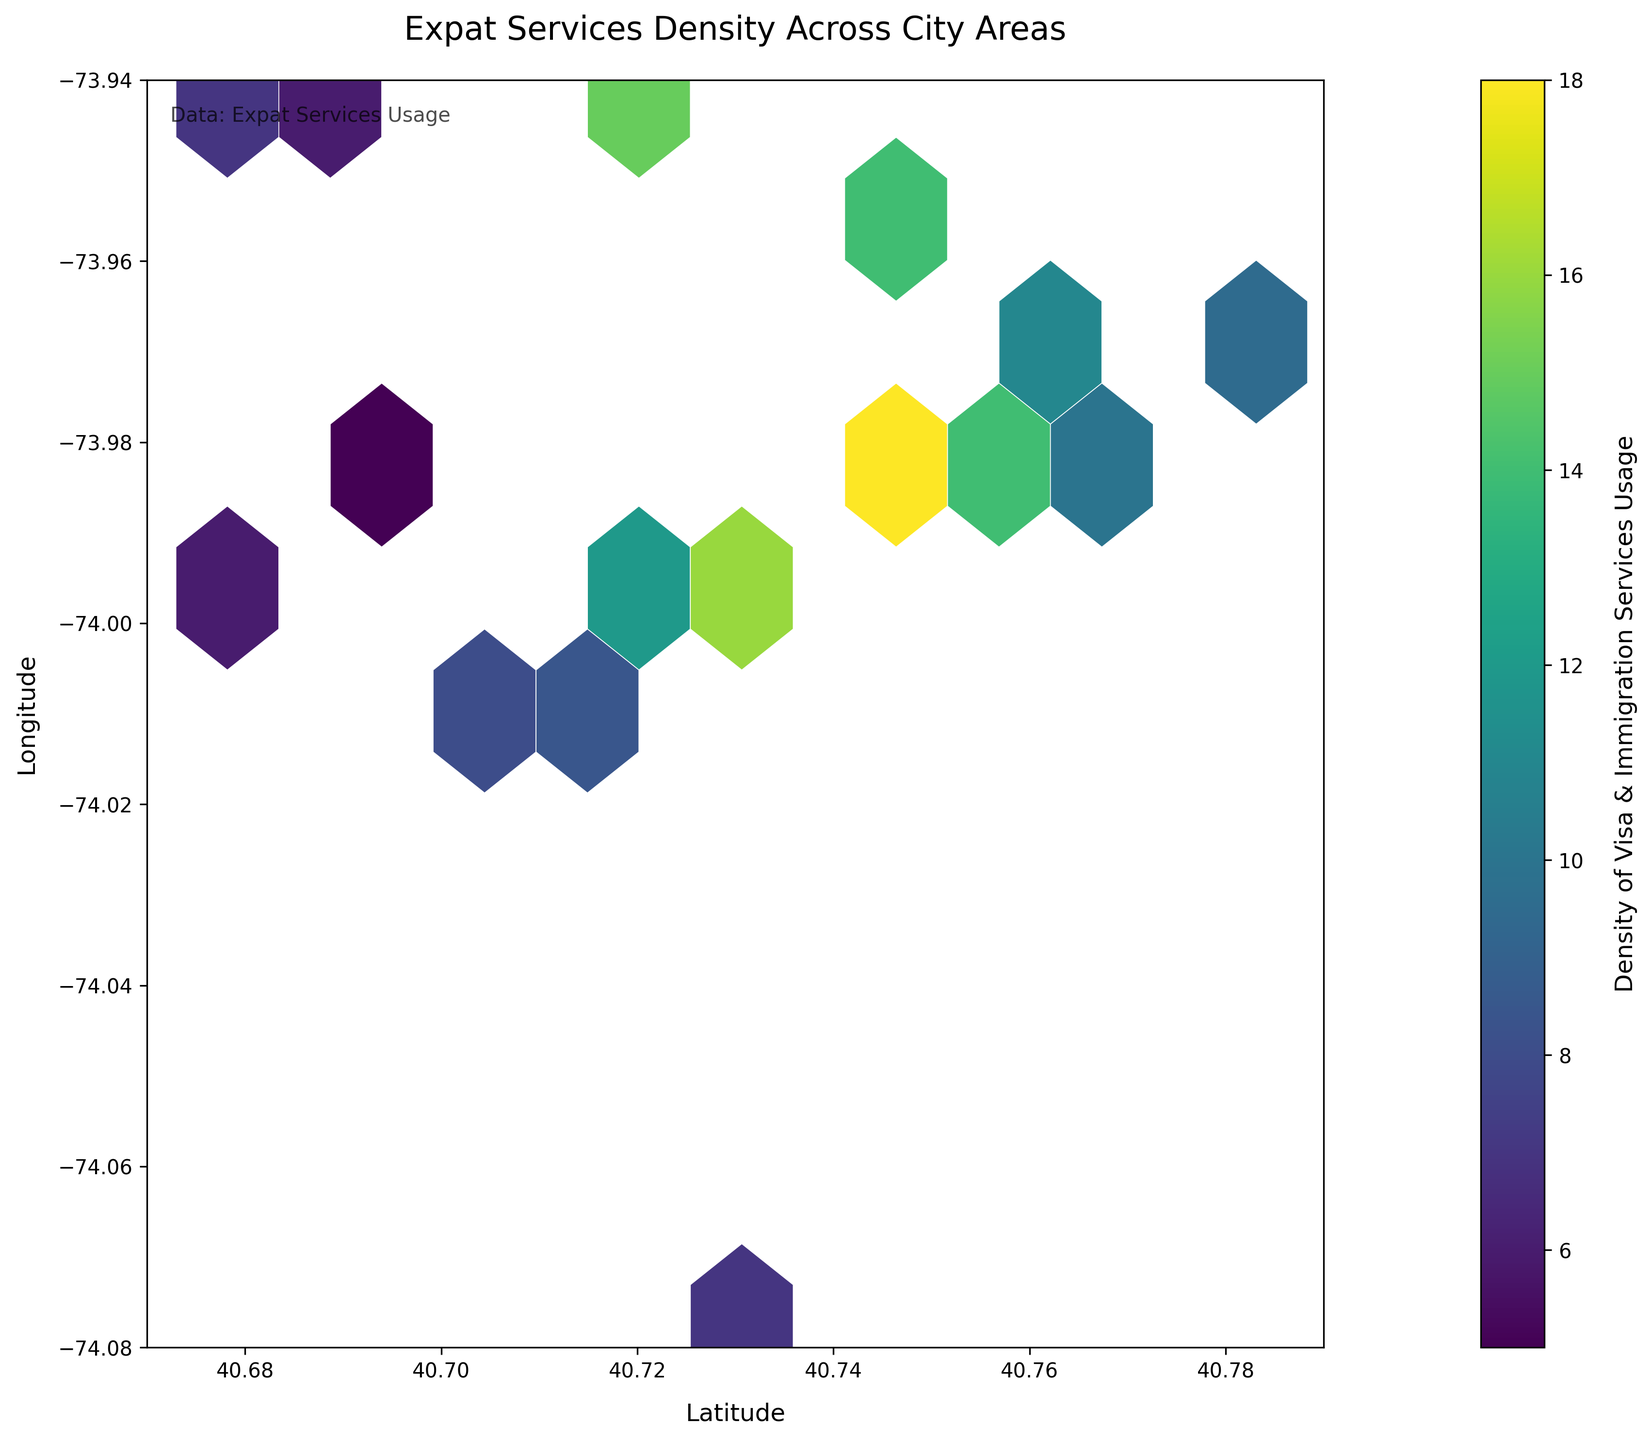what is the title of the plot? The title is located at the top of the plot and typically provides information about the subject of the plot. In this case, the title indicates what the plot is about.
Answer: Expat Services Density Across City Areas What latitude range is covered in the plot? The latitude range covers the horizontal axis, which can be identified by looking at the axis labels. This plot spans the latitude from approximately 40.67 to 40.79.
Answer: 40.67 to 40.79 Which area shows the highest density of visa and immigration services usage? The color bar indicates density, with brighter colors representing higher densities. The hexagon in the plot with the highest brightness indicates the highest usage.
Answer: Near 40.7484, -73.9857 What is the color associated with the highest density level? The color bar to the right of the plot maps specific colors to density levels, allowing you to determine the highest density color by looking at the top value.
Answer: Bright yellow Are there more high-density or low-density areas represented in the plot? By examining the plot and the distribution of hexagon colors, you can see whether there are more brighter (high-density) or darker (low-density) areas.
Answer: More low-density areas Which region shows more density: around 40.7589, -73.9851 or around 40.7831, -73.9712? By comparing the color intensity of hexagons around the given coordinates, you can conclude which one has a brighter color indicating more density.
Answer: 40.7589, -73.9851 What is the range of service usage density represented by the color bar? The color bar indicates the full range of values depicted in the plot, which is crucial for interpreting data density.
Answer: 5 to 18 How does the hexbin plot identify geographical areas with specific densities? The hexagonal bins and their color intensities are used to summarize and visually distinguish different data densities across the plotted area. This method helps to quickly identify geographical areas with specific service usage densities.
Answer: Hexagonal bins with varying color intensities How many geographical clusters can you identify with the density ranging from 10 to 15? By examining the plot and focusing on bins with colors that map to density values between 10 to 15 via the color bar, you can count the distinct clusters.
Answer: Approximately 7 Which side of the city appears to have more immigration service usage, the east or the west? By comparing the density across the plot's longitude axis (left side for west, right side for east), you can determine which side has higher overall density.
Answer: West 